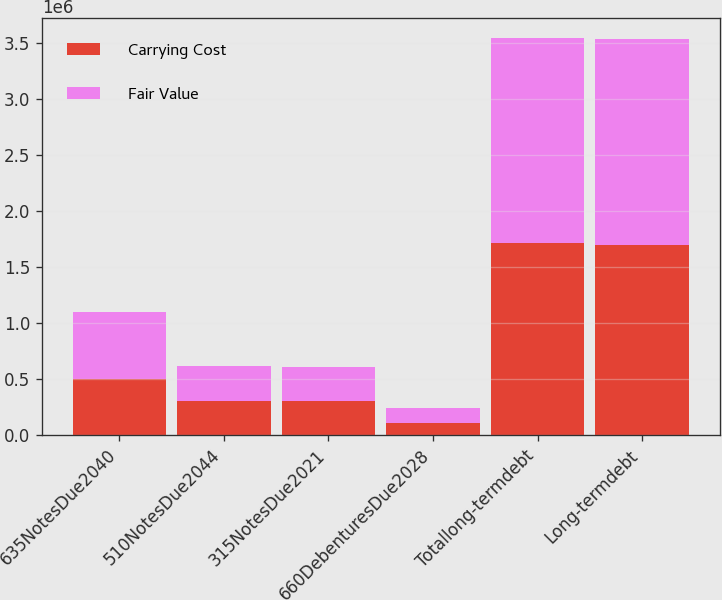Convert chart to OTSL. <chart><loc_0><loc_0><loc_500><loc_500><stacked_bar_chart><ecel><fcel>635NotesDue2040<fcel>510NotesDue2044<fcel>315NotesDue2021<fcel>660DebenturesDue2028<fcel>Totallong-termdebt<fcel>Long-termdebt<nl><fcel>Carrying Cost<fcel>500000<fcel>300000<fcel>300000<fcel>109895<fcel>1.7099e+06<fcel>1.69361e+06<nl><fcel>Fair Value<fcel>601800<fcel>313320<fcel>302640<fcel>131390<fcel>1.83745e+06<fcel>1.83745e+06<nl></chart> 